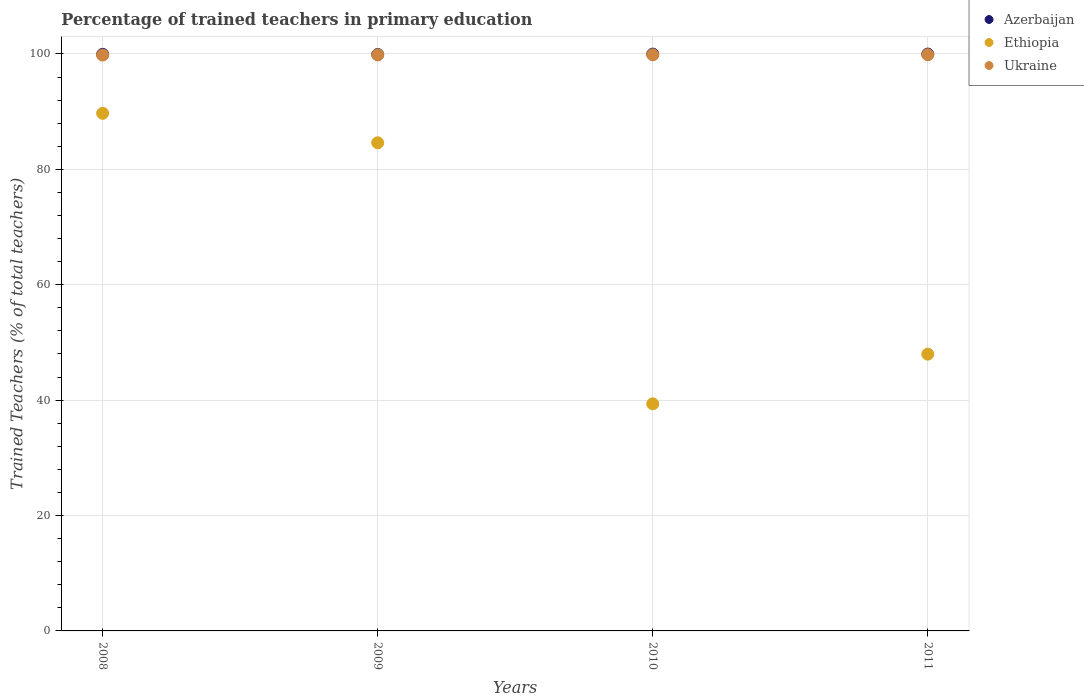Is the number of dotlines equal to the number of legend labels?
Your answer should be very brief. Yes. What is the percentage of trained teachers in Ukraine in 2008?
Keep it short and to the point. 99.82. Across all years, what is the maximum percentage of trained teachers in Azerbaijan?
Keep it short and to the point. 99.99. Across all years, what is the minimum percentage of trained teachers in Ukraine?
Provide a short and direct response. 99.82. What is the total percentage of trained teachers in Ukraine in the graph?
Ensure brevity in your answer.  399.41. What is the difference between the percentage of trained teachers in Ukraine in 2010 and that in 2011?
Provide a short and direct response. -0.01. What is the difference between the percentage of trained teachers in Ethiopia in 2010 and the percentage of trained teachers in Ukraine in 2009?
Offer a terse response. -60.49. What is the average percentage of trained teachers in Ethiopia per year?
Keep it short and to the point. 65.42. In the year 2010, what is the difference between the percentage of trained teachers in Ukraine and percentage of trained teachers in Azerbaijan?
Offer a terse response. -0.12. In how many years, is the percentage of trained teachers in Ukraine greater than 4 %?
Your answer should be very brief. 4. What is the ratio of the percentage of trained teachers in Ukraine in 2008 to that in 2010?
Keep it short and to the point. 1. Is the difference between the percentage of trained teachers in Ukraine in 2008 and 2011 greater than the difference between the percentage of trained teachers in Azerbaijan in 2008 and 2011?
Ensure brevity in your answer.  No. What is the difference between the highest and the second highest percentage of trained teachers in Ethiopia?
Offer a very short reply. 5.11. What is the difference between the highest and the lowest percentage of trained teachers in Ethiopia?
Your answer should be very brief. 50.35. In how many years, is the percentage of trained teachers in Azerbaijan greater than the average percentage of trained teachers in Azerbaijan taken over all years?
Offer a terse response. 2. Is it the case that in every year, the sum of the percentage of trained teachers in Ukraine and percentage of trained teachers in Ethiopia  is greater than the percentage of trained teachers in Azerbaijan?
Your answer should be compact. Yes. Does the percentage of trained teachers in Azerbaijan monotonically increase over the years?
Your answer should be very brief. No. Is the percentage of trained teachers in Azerbaijan strictly greater than the percentage of trained teachers in Ethiopia over the years?
Your response must be concise. Yes. How many dotlines are there?
Keep it short and to the point. 3. Where does the legend appear in the graph?
Provide a succinct answer. Top right. How are the legend labels stacked?
Your answer should be very brief. Vertical. What is the title of the graph?
Make the answer very short. Percentage of trained teachers in primary education. Does "Belgium" appear as one of the legend labels in the graph?
Offer a terse response. No. What is the label or title of the Y-axis?
Your response must be concise. Trained Teachers (% of total teachers). What is the Trained Teachers (% of total teachers) of Azerbaijan in 2008?
Offer a very short reply. 99.94. What is the Trained Teachers (% of total teachers) in Ethiopia in 2008?
Ensure brevity in your answer.  89.72. What is the Trained Teachers (% of total teachers) of Ukraine in 2008?
Your answer should be compact. 99.82. What is the Trained Teachers (% of total teachers) of Azerbaijan in 2009?
Offer a terse response. 99.92. What is the Trained Teachers (% of total teachers) of Ethiopia in 2009?
Your answer should be compact. 84.61. What is the Trained Teachers (% of total teachers) of Ukraine in 2009?
Your response must be concise. 99.86. What is the Trained Teachers (% of total teachers) of Azerbaijan in 2010?
Your answer should be compact. 99.98. What is the Trained Teachers (% of total teachers) in Ethiopia in 2010?
Make the answer very short. 39.36. What is the Trained Teachers (% of total teachers) in Ukraine in 2010?
Give a very brief answer. 99.86. What is the Trained Teachers (% of total teachers) of Azerbaijan in 2011?
Offer a terse response. 99.99. What is the Trained Teachers (% of total teachers) in Ethiopia in 2011?
Your response must be concise. 47.97. What is the Trained Teachers (% of total teachers) of Ukraine in 2011?
Offer a terse response. 99.87. Across all years, what is the maximum Trained Teachers (% of total teachers) in Azerbaijan?
Your answer should be very brief. 99.99. Across all years, what is the maximum Trained Teachers (% of total teachers) of Ethiopia?
Your answer should be very brief. 89.72. Across all years, what is the maximum Trained Teachers (% of total teachers) of Ukraine?
Make the answer very short. 99.87. Across all years, what is the minimum Trained Teachers (% of total teachers) of Azerbaijan?
Offer a very short reply. 99.92. Across all years, what is the minimum Trained Teachers (% of total teachers) of Ethiopia?
Provide a succinct answer. 39.36. Across all years, what is the minimum Trained Teachers (% of total teachers) of Ukraine?
Give a very brief answer. 99.82. What is the total Trained Teachers (% of total teachers) in Azerbaijan in the graph?
Your answer should be compact. 399.82. What is the total Trained Teachers (% of total teachers) in Ethiopia in the graph?
Your answer should be very brief. 261.66. What is the total Trained Teachers (% of total teachers) of Ukraine in the graph?
Offer a terse response. 399.41. What is the difference between the Trained Teachers (% of total teachers) in Azerbaijan in 2008 and that in 2009?
Provide a short and direct response. 0.02. What is the difference between the Trained Teachers (% of total teachers) of Ethiopia in 2008 and that in 2009?
Your answer should be very brief. 5.11. What is the difference between the Trained Teachers (% of total teachers) of Ukraine in 2008 and that in 2009?
Your answer should be compact. -0.04. What is the difference between the Trained Teachers (% of total teachers) of Azerbaijan in 2008 and that in 2010?
Your answer should be compact. -0.04. What is the difference between the Trained Teachers (% of total teachers) in Ethiopia in 2008 and that in 2010?
Provide a short and direct response. 50.35. What is the difference between the Trained Teachers (% of total teachers) of Ukraine in 2008 and that in 2010?
Offer a terse response. -0.05. What is the difference between the Trained Teachers (% of total teachers) of Azerbaijan in 2008 and that in 2011?
Offer a very short reply. -0.05. What is the difference between the Trained Teachers (% of total teachers) in Ethiopia in 2008 and that in 2011?
Your response must be concise. 41.74. What is the difference between the Trained Teachers (% of total teachers) in Ukraine in 2008 and that in 2011?
Provide a short and direct response. -0.06. What is the difference between the Trained Teachers (% of total teachers) of Azerbaijan in 2009 and that in 2010?
Ensure brevity in your answer.  -0.06. What is the difference between the Trained Teachers (% of total teachers) of Ethiopia in 2009 and that in 2010?
Keep it short and to the point. 45.25. What is the difference between the Trained Teachers (% of total teachers) of Ukraine in 2009 and that in 2010?
Your response must be concise. -0.01. What is the difference between the Trained Teachers (% of total teachers) of Azerbaijan in 2009 and that in 2011?
Provide a succinct answer. -0.07. What is the difference between the Trained Teachers (% of total teachers) of Ethiopia in 2009 and that in 2011?
Make the answer very short. 36.64. What is the difference between the Trained Teachers (% of total teachers) of Ukraine in 2009 and that in 2011?
Your answer should be very brief. -0.02. What is the difference between the Trained Teachers (% of total teachers) in Azerbaijan in 2010 and that in 2011?
Your answer should be compact. -0.01. What is the difference between the Trained Teachers (% of total teachers) in Ethiopia in 2010 and that in 2011?
Make the answer very short. -8.61. What is the difference between the Trained Teachers (% of total teachers) in Ukraine in 2010 and that in 2011?
Keep it short and to the point. -0.01. What is the difference between the Trained Teachers (% of total teachers) of Azerbaijan in 2008 and the Trained Teachers (% of total teachers) of Ethiopia in 2009?
Your response must be concise. 15.33. What is the difference between the Trained Teachers (% of total teachers) of Azerbaijan in 2008 and the Trained Teachers (% of total teachers) of Ukraine in 2009?
Offer a very short reply. 0.09. What is the difference between the Trained Teachers (% of total teachers) in Ethiopia in 2008 and the Trained Teachers (% of total teachers) in Ukraine in 2009?
Provide a succinct answer. -10.14. What is the difference between the Trained Teachers (% of total teachers) of Azerbaijan in 2008 and the Trained Teachers (% of total teachers) of Ethiopia in 2010?
Provide a succinct answer. 60.58. What is the difference between the Trained Teachers (% of total teachers) of Azerbaijan in 2008 and the Trained Teachers (% of total teachers) of Ukraine in 2010?
Your answer should be very brief. 0.08. What is the difference between the Trained Teachers (% of total teachers) in Ethiopia in 2008 and the Trained Teachers (% of total teachers) in Ukraine in 2010?
Give a very brief answer. -10.15. What is the difference between the Trained Teachers (% of total teachers) of Azerbaijan in 2008 and the Trained Teachers (% of total teachers) of Ethiopia in 2011?
Your answer should be compact. 51.97. What is the difference between the Trained Teachers (% of total teachers) in Azerbaijan in 2008 and the Trained Teachers (% of total teachers) in Ukraine in 2011?
Make the answer very short. 0.07. What is the difference between the Trained Teachers (% of total teachers) of Ethiopia in 2008 and the Trained Teachers (% of total teachers) of Ukraine in 2011?
Keep it short and to the point. -10.16. What is the difference between the Trained Teachers (% of total teachers) of Azerbaijan in 2009 and the Trained Teachers (% of total teachers) of Ethiopia in 2010?
Give a very brief answer. 60.55. What is the difference between the Trained Teachers (% of total teachers) in Azerbaijan in 2009 and the Trained Teachers (% of total teachers) in Ukraine in 2010?
Keep it short and to the point. 0.05. What is the difference between the Trained Teachers (% of total teachers) in Ethiopia in 2009 and the Trained Teachers (% of total teachers) in Ukraine in 2010?
Offer a very short reply. -15.25. What is the difference between the Trained Teachers (% of total teachers) of Azerbaijan in 2009 and the Trained Teachers (% of total teachers) of Ethiopia in 2011?
Keep it short and to the point. 51.94. What is the difference between the Trained Teachers (% of total teachers) in Azerbaijan in 2009 and the Trained Teachers (% of total teachers) in Ukraine in 2011?
Your answer should be compact. 0.04. What is the difference between the Trained Teachers (% of total teachers) of Ethiopia in 2009 and the Trained Teachers (% of total teachers) of Ukraine in 2011?
Provide a succinct answer. -15.26. What is the difference between the Trained Teachers (% of total teachers) in Azerbaijan in 2010 and the Trained Teachers (% of total teachers) in Ethiopia in 2011?
Offer a very short reply. 52.01. What is the difference between the Trained Teachers (% of total teachers) in Azerbaijan in 2010 and the Trained Teachers (% of total teachers) in Ukraine in 2011?
Your answer should be very brief. 0.11. What is the difference between the Trained Teachers (% of total teachers) of Ethiopia in 2010 and the Trained Teachers (% of total teachers) of Ukraine in 2011?
Your response must be concise. -60.51. What is the average Trained Teachers (% of total teachers) in Azerbaijan per year?
Give a very brief answer. 99.96. What is the average Trained Teachers (% of total teachers) of Ethiopia per year?
Offer a very short reply. 65.42. What is the average Trained Teachers (% of total teachers) in Ukraine per year?
Provide a succinct answer. 99.85. In the year 2008, what is the difference between the Trained Teachers (% of total teachers) in Azerbaijan and Trained Teachers (% of total teachers) in Ethiopia?
Provide a short and direct response. 10.22. In the year 2008, what is the difference between the Trained Teachers (% of total teachers) of Azerbaijan and Trained Teachers (% of total teachers) of Ukraine?
Your answer should be very brief. 0.13. In the year 2008, what is the difference between the Trained Teachers (% of total teachers) of Ethiopia and Trained Teachers (% of total teachers) of Ukraine?
Offer a very short reply. -10.1. In the year 2009, what is the difference between the Trained Teachers (% of total teachers) of Azerbaijan and Trained Teachers (% of total teachers) of Ethiopia?
Provide a succinct answer. 15.31. In the year 2009, what is the difference between the Trained Teachers (% of total teachers) of Azerbaijan and Trained Teachers (% of total teachers) of Ukraine?
Keep it short and to the point. 0.06. In the year 2009, what is the difference between the Trained Teachers (% of total teachers) in Ethiopia and Trained Teachers (% of total teachers) in Ukraine?
Offer a very short reply. -15.25. In the year 2010, what is the difference between the Trained Teachers (% of total teachers) of Azerbaijan and Trained Teachers (% of total teachers) of Ethiopia?
Offer a very short reply. 60.62. In the year 2010, what is the difference between the Trained Teachers (% of total teachers) of Azerbaijan and Trained Teachers (% of total teachers) of Ukraine?
Ensure brevity in your answer.  0.12. In the year 2010, what is the difference between the Trained Teachers (% of total teachers) of Ethiopia and Trained Teachers (% of total teachers) of Ukraine?
Your answer should be compact. -60.5. In the year 2011, what is the difference between the Trained Teachers (% of total teachers) of Azerbaijan and Trained Teachers (% of total teachers) of Ethiopia?
Keep it short and to the point. 52.01. In the year 2011, what is the difference between the Trained Teachers (% of total teachers) in Azerbaijan and Trained Teachers (% of total teachers) in Ukraine?
Provide a succinct answer. 0.12. In the year 2011, what is the difference between the Trained Teachers (% of total teachers) in Ethiopia and Trained Teachers (% of total teachers) in Ukraine?
Your answer should be very brief. -51.9. What is the ratio of the Trained Teachers (% of total teachers) of Ethiopia in 2008 to that in 2009?
Your response must be concise. 1.06. What is the ratio of the Trained Teachers (% of total teachers) in Ukraine in 2008 to that in 2009?
Your answer should be compact. 1. What is the ratio of the Trained Teachers (% of total teachers) in Azerbaijan in 2008 to that in 2010?
Your answer should be compact. 1. What is the ratio of the Trained Teachers (% of total teachers) in Ethiopia in 2008 to that in 2010?
Make the answer very short. 2.28. What is the ratio of the Trained Teachers (% of total teachers) of Ukraine in 2008 to that in 2010?
Make the answer very short. 1. What is the ratio of the Trained Teachers (% of total teachers) of Azerbaijan in 2008 to that in 2011?
Offer a terse response. 1. What is the ratio of the Trained Teachers (% of total teachers) in Ethiopia in 2008 to that in 2011?
Ensure brevity in your answer.  1.87. What is the ratio of the Trained Teachers (% of total teachers) of Ukraine in 2008 to that in 2011?
Ensure brevity in your answer.  1. What is the ratio of the Trained Teachers (% of total teachers) of Ethiopia in 2009 to that in 2010?
Offer a terse response. 2.15. What is the ratio of the Trained Teachers (% of total teachers) in Ukraine in 2009 to that in 2010?
Ensure brevity in your answer.  1. What is the ratio of the Trained Teachers (% of total teachers) in Azerbaijan in 2009 to that in 2011?
Provide a succinct answer. 1. What is the ratio of the Trained Teachers (% of total teachers) of Ethiopia in 2009 to that in 2011?
Ensure brevity in your answer.  1.76. What is the ratio of the Trained Teachers (% of total teachers) of Ethiopia in 2010 to that in 2011?
Keep it short and to the point. 0.82. What is the ratio of the Trained Teachers (% of total teachers) of Ukraine in 2010 to that in 2011?
Make the answer very short. 1. What is the difference between the highest and the second highest Trained Teachers (% of total teachers) in Azerbaijan?
Make the answer very short. 0.01. What is the difference between the highest and the second highest Trained Teachers (% of total teachers) in Ethiopia?
Provide a succinct answer. 5.11. What is the difference between the highest and the second highest Trained Teachers (% of total teachers) of Ukraine?
Your answer should be compact. 0.01. What is the difference between the highest and the lowest Trained Teachers (% of total teachers) in Azerbaijan?
Provide a succinct answer. 0.07. What is the difference between the highest and the lowest Trained Teachers (% of total teachers) in Ethiopia?
Your answer should be very brief. 50.35. What is the difference between the highest and the lowest Trained Teachers (% of total teachers) of Ukraine?
Your answer should be compact. 0.06. 